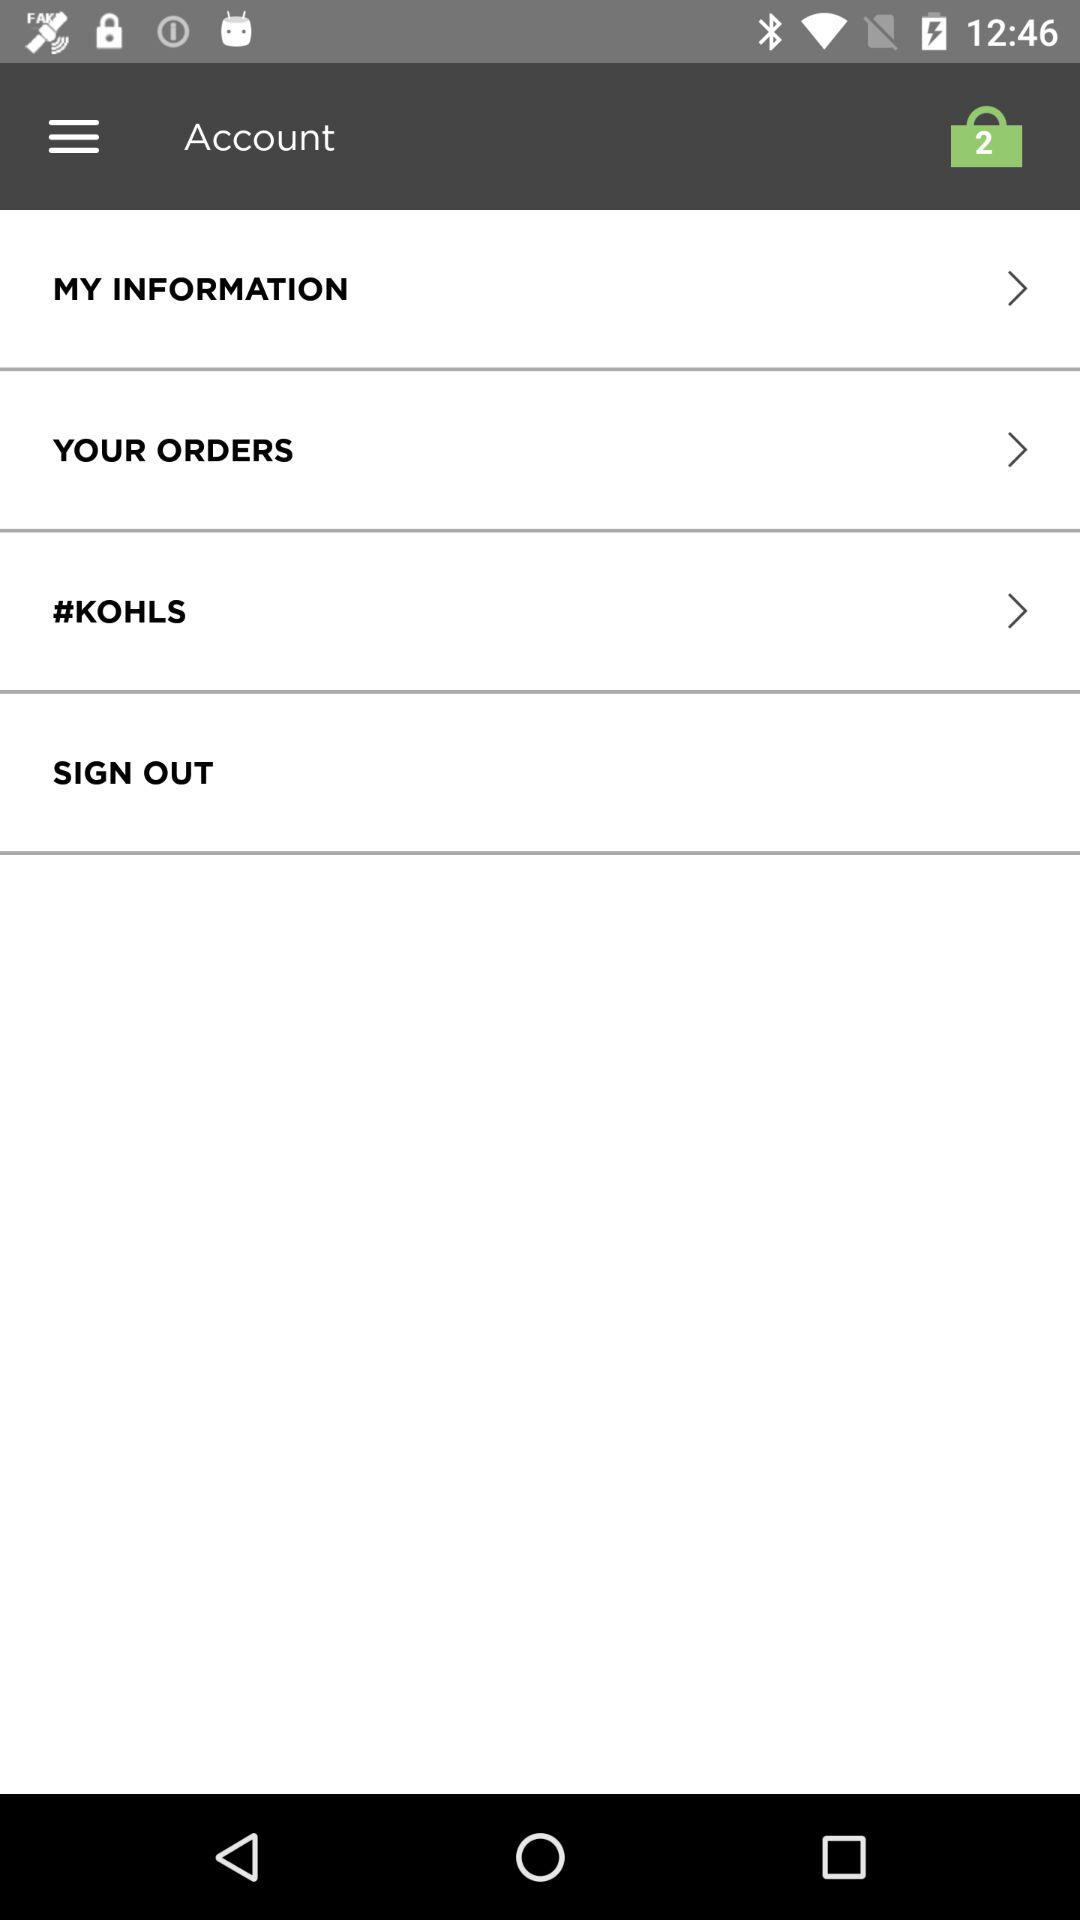How many past orders are there?
When the provided information is insufficient, respond with <no answer>. <no answer> 